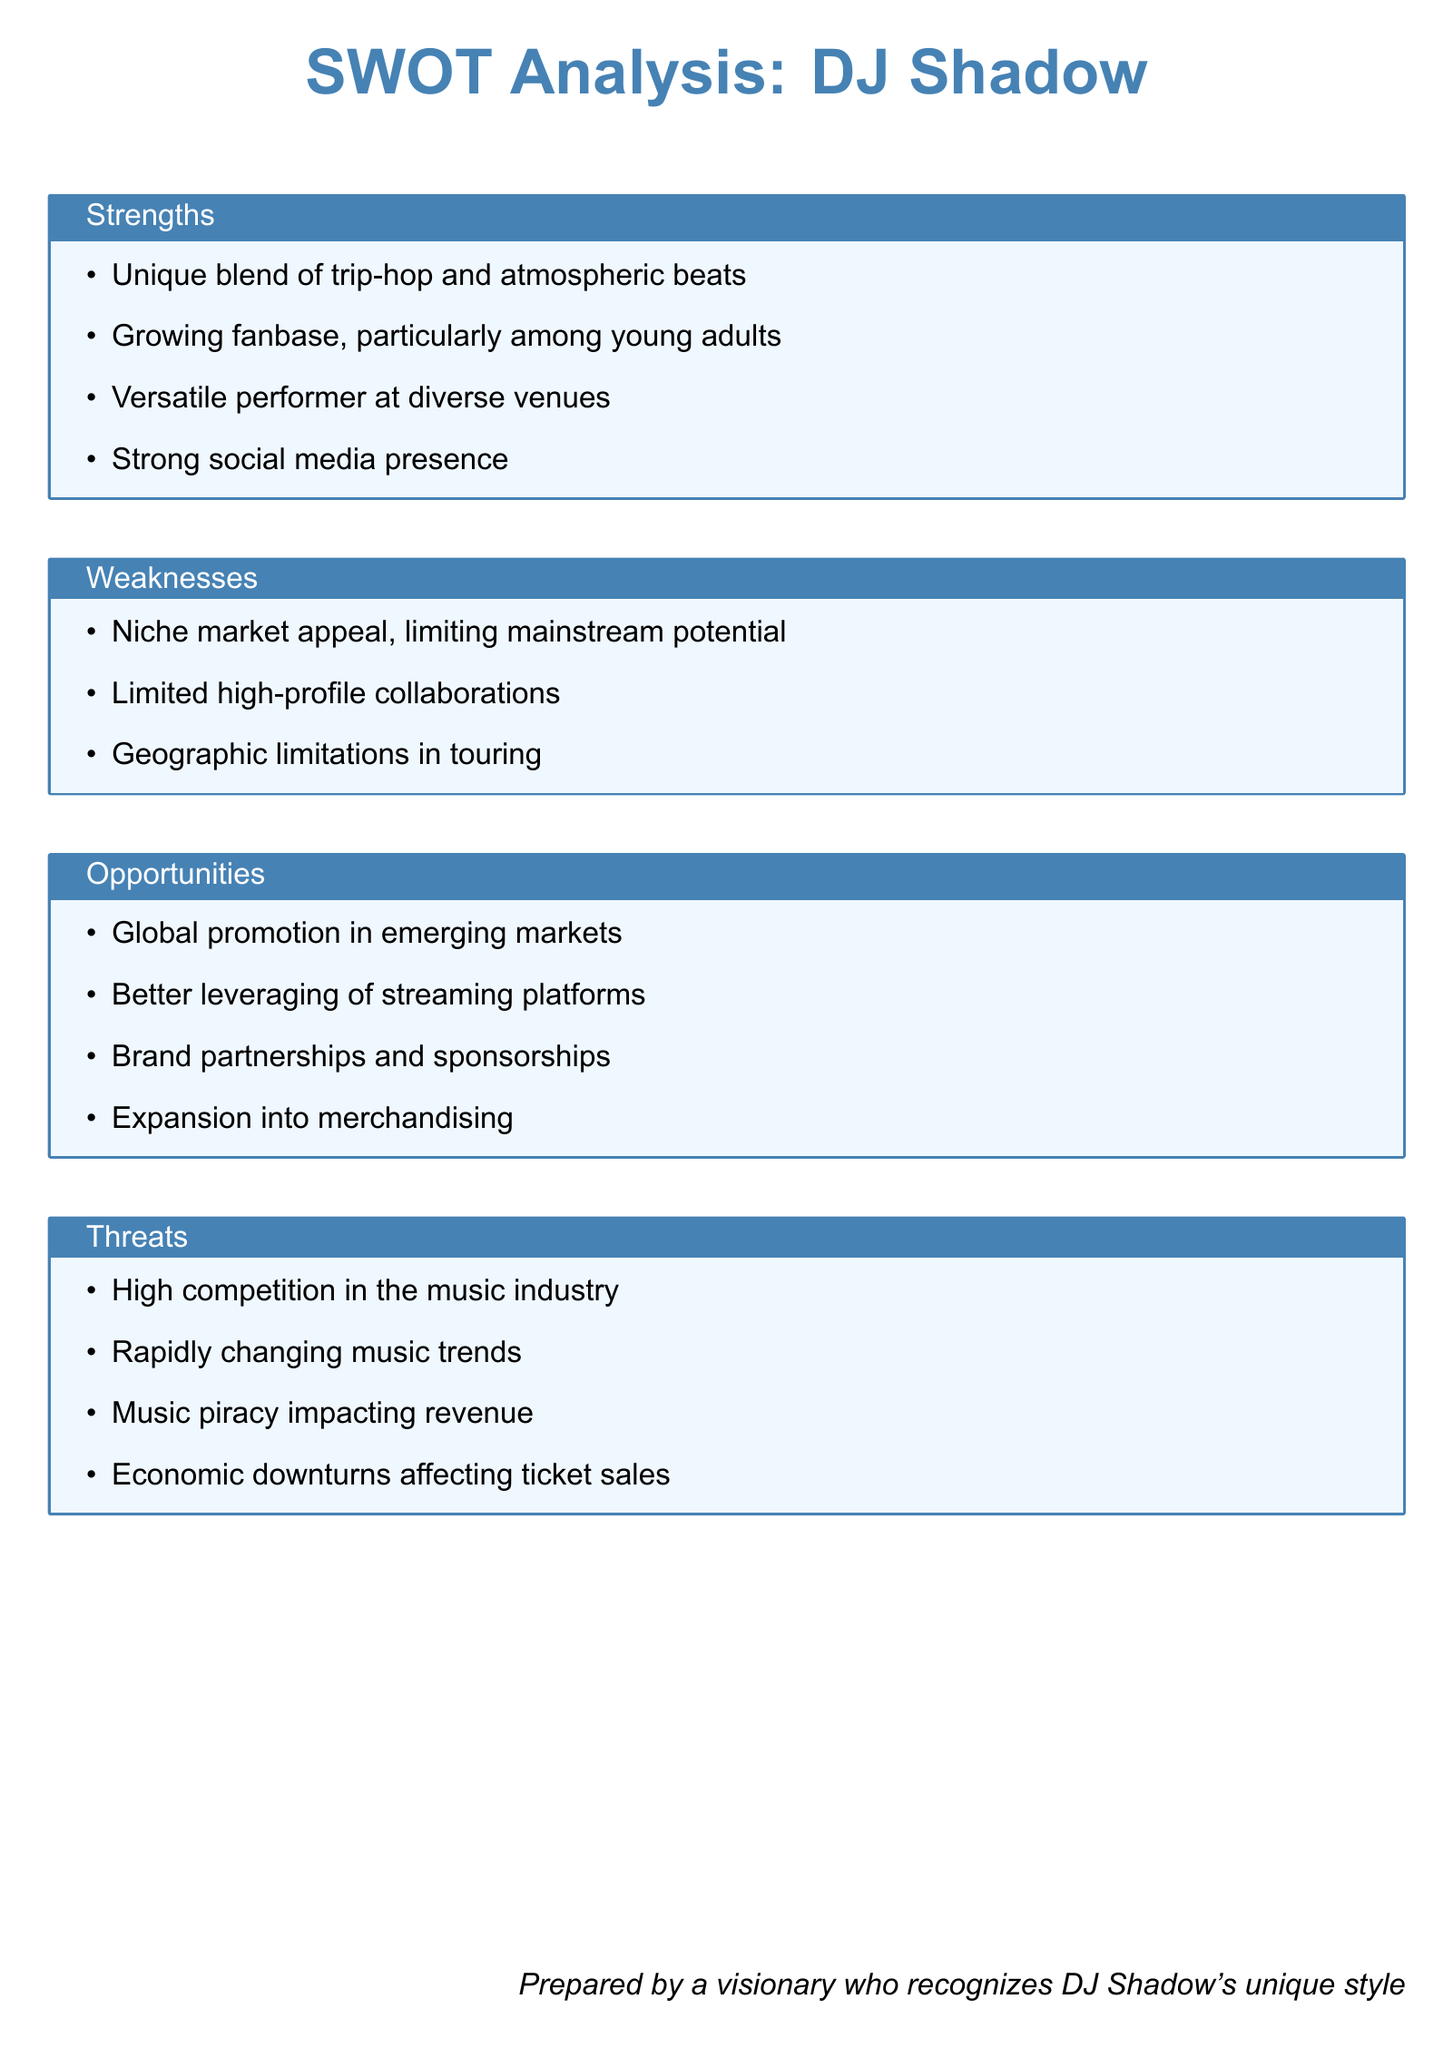What is DJ Shadow's unique musical style? DJ Shadow's unique musical style is a blend of trip-hop and atmospheric beats.
Answer: trip-hop and atmospheric beats What audience is DJ Shadow's fanbase growing among? The document states that DJ Shadow's fanbase is growing particularly among young adults.
Answer: young adults What is a weakness regarding DJ Shadow's market appeal? The weakness mentioned in the document is that DJ Shadow has niche market appeal, limiting mainstream potential.
Answer: niche market appeal What opportunity is suggested for brand partnerships? The document indicates that brand partnerships and sponsorships are an opportunity for DJ Shadow.
Answer: brand partnerships and sponsorships What threat could impact ticket sales? The document mentions that economic downturns could affect ticket sales.
Answer: economic downturns How is DJ Shadow's social media presence described? DJ Shadow has a strong social media presence, as stated in the document.
Answer: strong social media presence What is one geographic limitation in touring for DJ Shadow? The document highlights that geographic limitations exist in DJ Shadow's touring.
Answer: geographic limitations Which digital platform is an opportunity for better leveraging? The document specifies that there is an opportunity to better leverage streaming platforms.
Answer: streaming platforms 